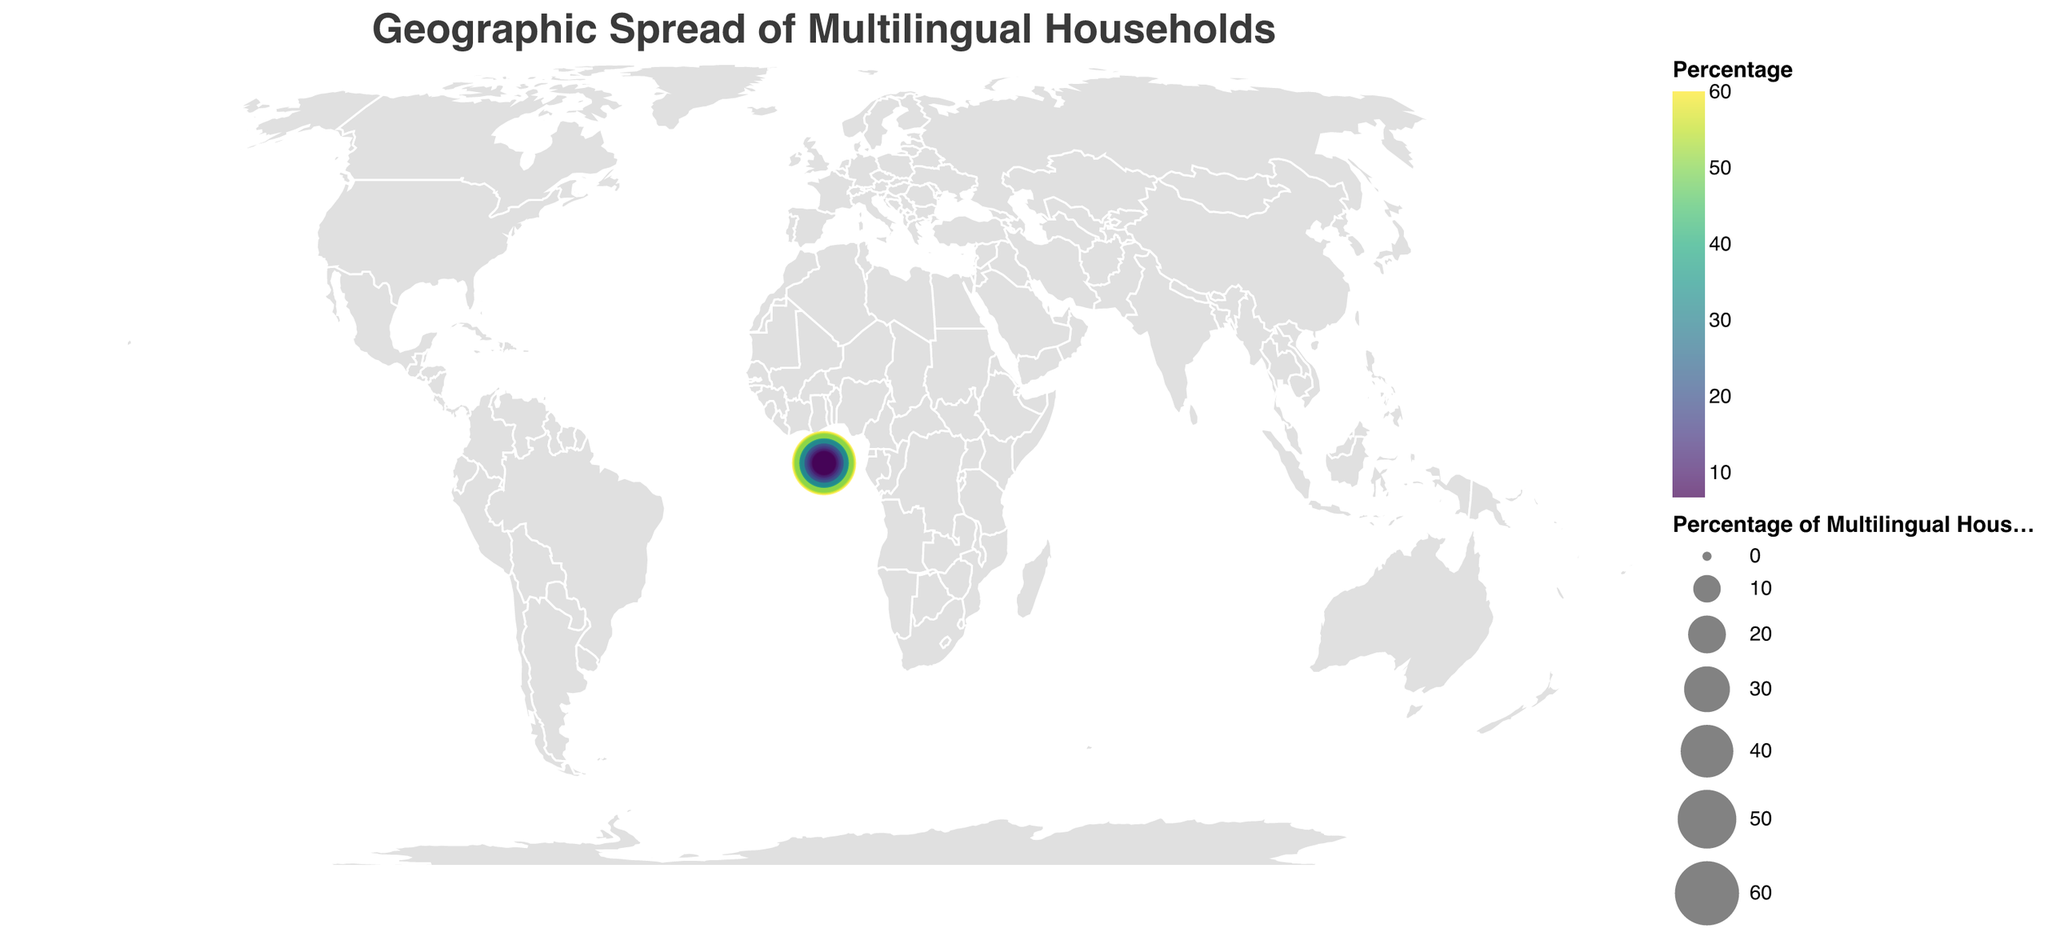What is the title of the plot? The title of the plot is prominently displayed at the top and reads "Geographic Spread of Multilingual Households".
Answer: Geographic Spread of Multilingual Households Which country has the highest percentage of multilingual households? By examining the plot, the country with the largest circle, indicating the highest percentage, is Switzerland at 60.1%.
Answer: Switzerland What is the percentage of multilingual households in Japan? Hovering over or looking at the corresponding point for Japan in the figure reveals the percentage to be 11.8%.
Answer: 11.8% Compare the percentage of multilingual households between the United Kingdom and France. Which country has a higher percentage? By comparing the circles for the United Kingdom and France, the UK has a higher percentage (18.7%) compared to France (16.2%).
Answer: United Kingdom What is the approximate average percentage of multilingual households among Switzerland, Luxembourg, and Singapore? The percentages for Switzerland, Luxembourg, and Singapore are 60.1, 55.8, and 52.3 respectively. Adding these together (60.1 + 55.8 + 52.3) equals 168.2, and dividing by 3 gives an average of approximately 56.1%.
Answer: 56.1 Which country has a lower percentage of multilingual households: Russia or China? Comparing the data points for Russia and China, Russia has a lower percentage (8.7%) compared to China (7.5%).
Answer: China Identify the country with the lowest percentage of multilingual households and state the percentage. The smallest circle indicates the country with the lowest percentage, which is Mexico at 6.8%.
Answer: Mexico What is the total percentage of multilingual households for Belgium, Netherlands, and Germany combined? The percentages for Belgium (49.7), Netherlands (30.6), and Germany (20.8) sum up to (49.7 + 30.6 + 20.8) = 101.1%.
Answer: 101.1 Approximately how many countries have less than 20% multilingual households according to the plot? Counting the number of circles with percentages below 20% (United States, Australia, Germany, United Kingdom, France, Italy, Japan, Brazil, Russia, China, and Mexico) sums up to 11 countries.
Answer: 11 Which color scheme is used to represent the percentage values in the plot? The color scheme used in the plot is viridis, as evidenced by the gradient color representation on the legend.
Answer: viridis 